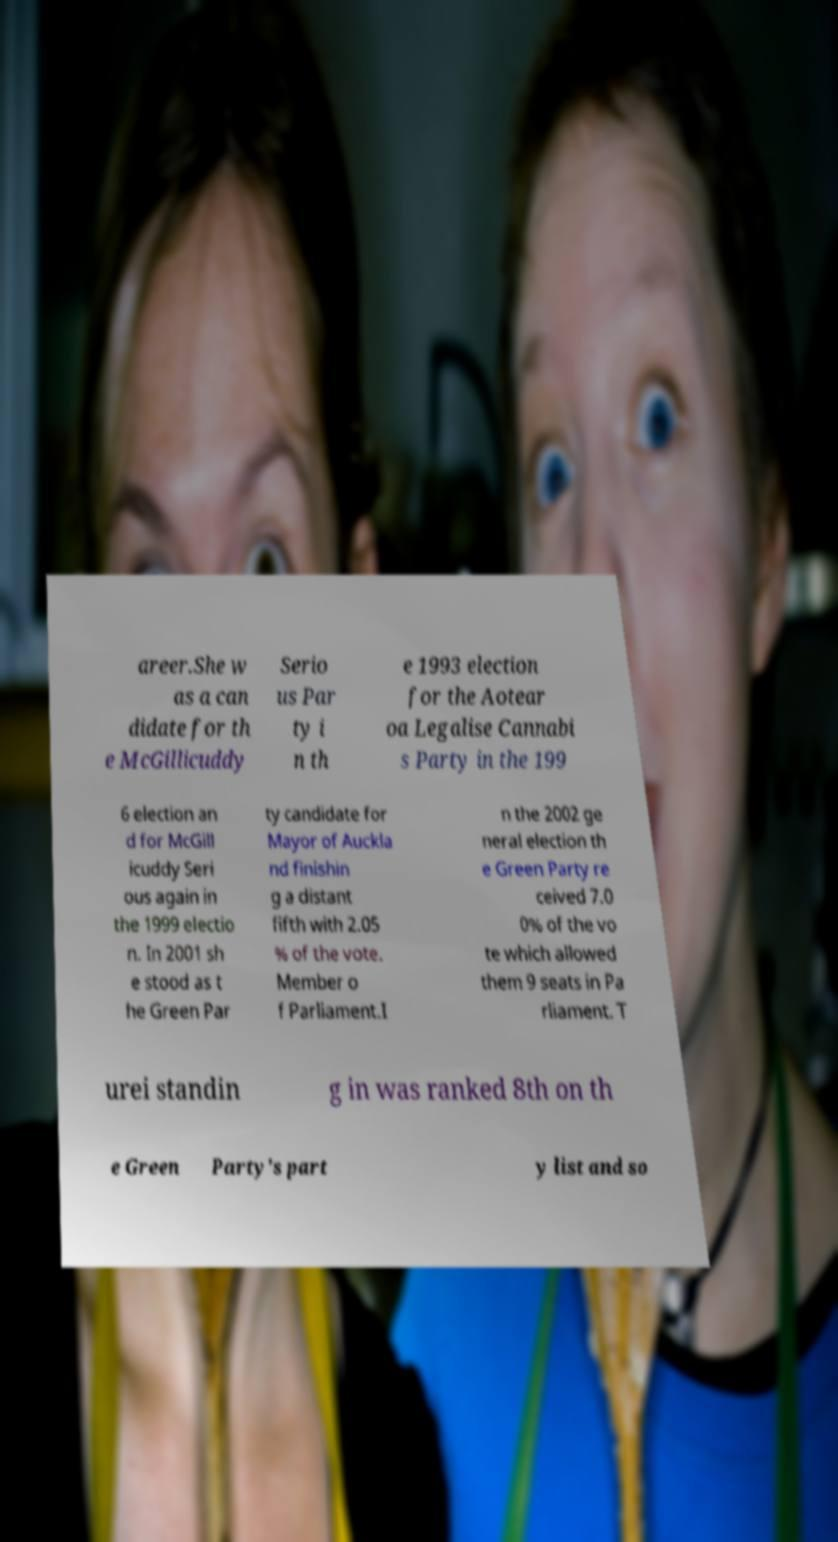Could you extract and type out the text from this image? areer.She w as a can didate for th e McGillicuddy Serio us Par ty i n th e 1993 election for the Aotear oa Legalise Cannabi s Party in the 199 6 election an d for McGill icuddy Seri ous again in the 1999 electio n. In 2001 sh e stood as t he Green Par ty candidate for Mayor of Auckla nd finishin g a distant fifth with 2.05 % of the vote. Member o f Parliament.I n the 2002 ge neral election th e Green Party re ceived 7.0 0% of the vo te which allowed them 9 seats in Pa rliament. T urei standin g in was ranked 8th on th e Green Party's part y list and so 